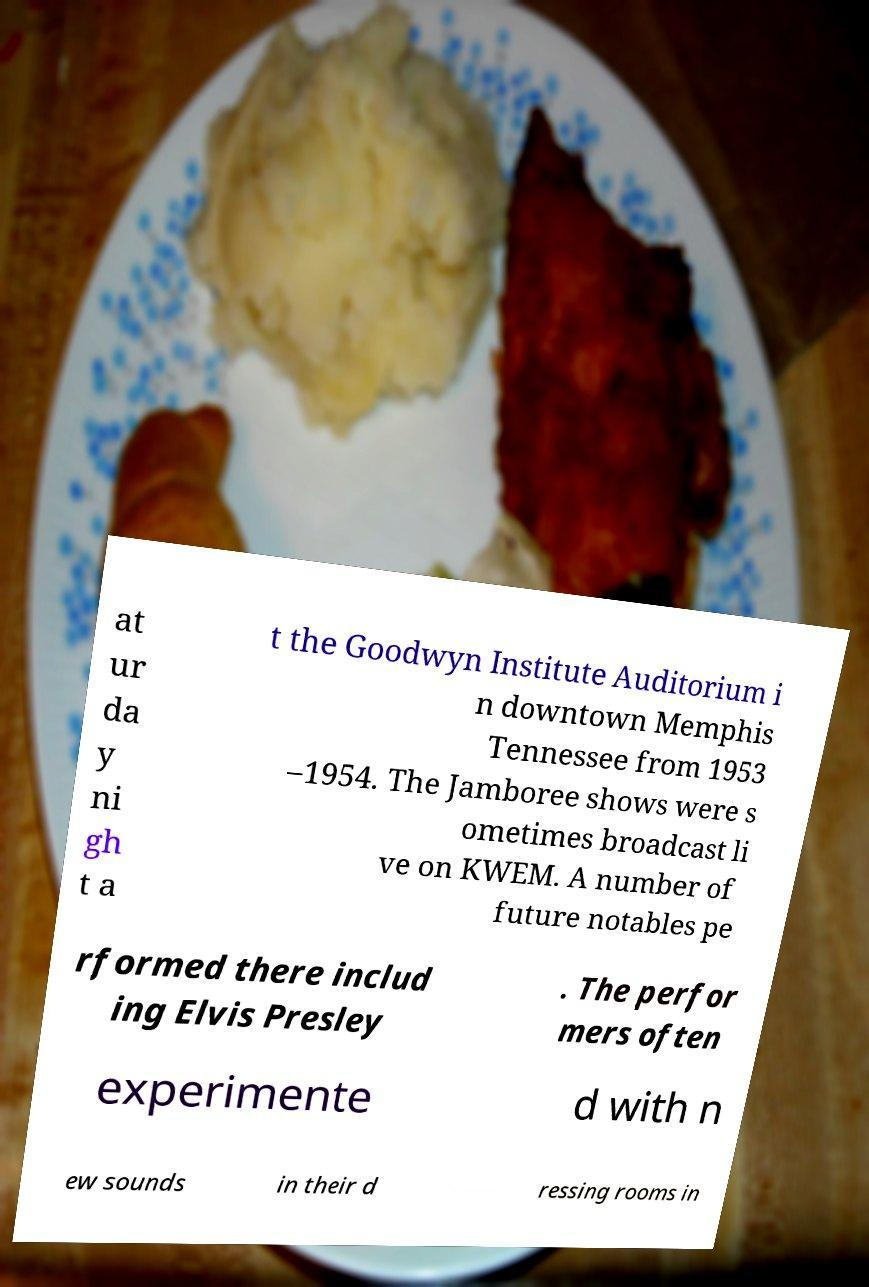Please read and relay the text visible in this image. What does it say? at ur da y ni gh t a t the Goodwyn Institute Auditorium i n downtown Memphis Tennessee from 1953 –1954. The Jamboree shows were s ometimes broadcast li ve on KWEM. A number of future notables pe rformed there includ ing Elvis Presley . The perfor mers often experimente d with n ew sounds in their d ressing rooms in 